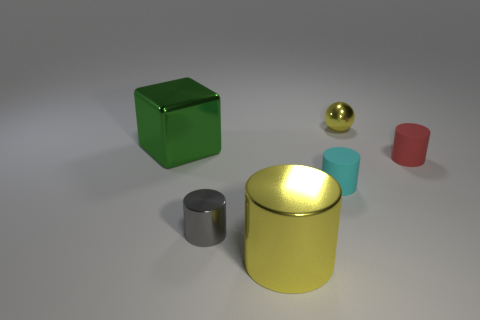There is a big thing that is the same color as the ball; what is it made of?
Offer a very short reply. Metal. What shape is the object that is the same color as the big cylinder?
Your response must be concise. Sphere. What number of things are either metallic objects in front of the gray shiny cylinder or cyan shiny cylinders?
Give a very brief answer. 1. There is a large cylinder in front of the cyan thing; how many objects are in front of it?
Make the answer very short. 0. Are there fewer gray shiny objects to the left of the gray metallic cylinder than tiny gray shiny cylinders that are behind the small yellow shiny ball?
Your response must be concise. No. What is the shape of the small rubber thing that is on the right side of the tiny metal object on the right side of the cyan cylinder?
Your response must be concise. Cylinder. What number of other things are the same material as the red cylinder?
Provide a succinct answer. 1. Are there any other things that have the same size as the metal cube?
Your answer should be very brief. Yes. Are there more purple cylinders than tiny yellow things?
Offer a very short reply. No. How big is the thing right of the yellow thing behind the yellow object in front of the green object?
Keep it short and to the point. Small. 